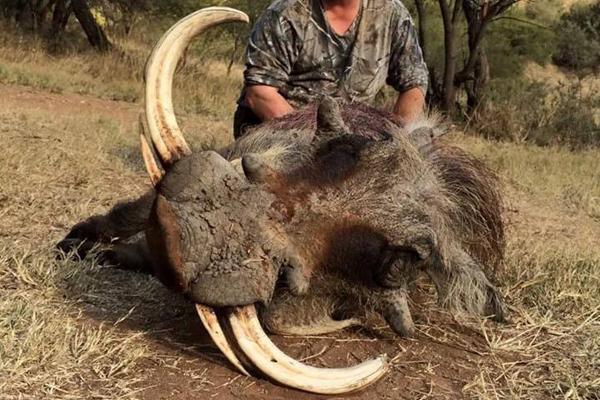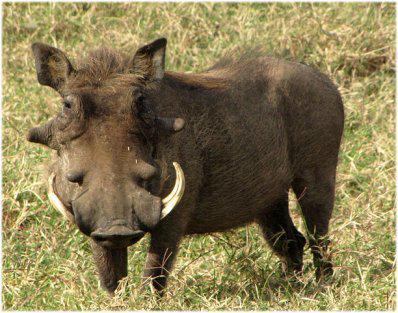The first image is the image on the left, the second image is the image on the right. For the images displayed, is the sentence "An image shows at least one mammal behind the hog in the foreground." factually correct? Answer yes or no. Yes. 